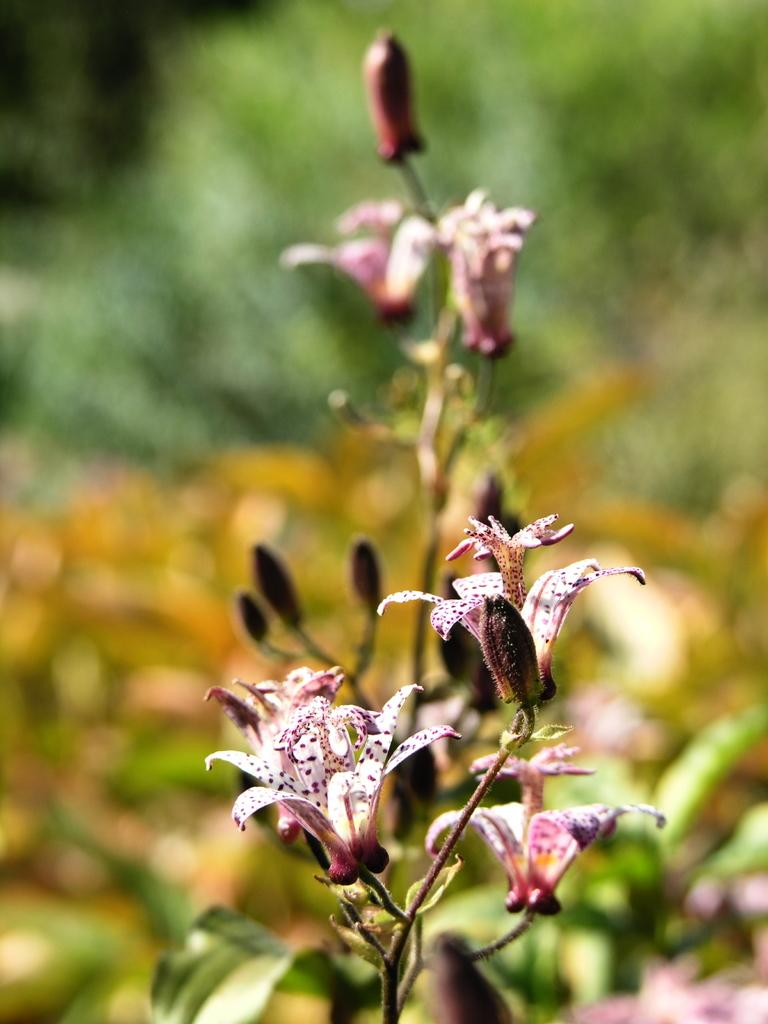What type of plants are visible in the image? There are plants with flowers in the image. What stage of growth are the plants in? The plants have buds. Can you describe the background of the image? The background of the image is blurred. What type of ornament is placed on the sofa in the image? There is no sofa or ornament present in the image; it only features plants with flowers and a blurred background. 